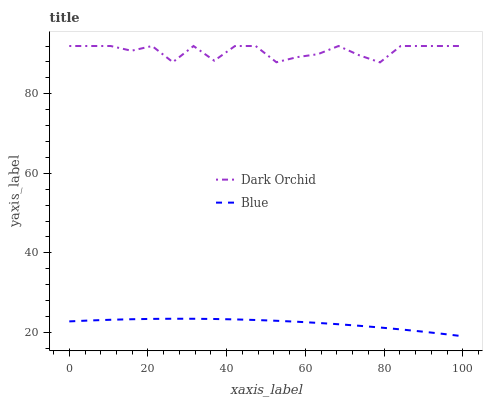Does Blue have the minimum area under the curve?
Answer yes or no. Yes. Does Dark Orchid have the maximum area under the curve?
Answer yes or no. Yes. Does Dark Orchid have the minimum area under the curve?
Answer yes or no. No. Is Blue the smoothest?
Answer yes or no. Yes. Is Dark Orchid the roughest?
Answer yes or no. Yes. Is Dark Orchid the smoothest?
Answer yes or no. No. Does Blue have the lowest value?
Answer yes or no. Yes. Does Dark Orchid have the lowest value?
Answer yes or no. No. Does Dark Orchid have the highest value?
Answer yes or no. Yes. Is Blue less than Dark Orchid?
Answer yes or no. Yes. Is Dark Orchid greater than Blue?
Answer yes or no. Yes. Does Blue intersect Dark Orchid?
Answer yes or no. No. 